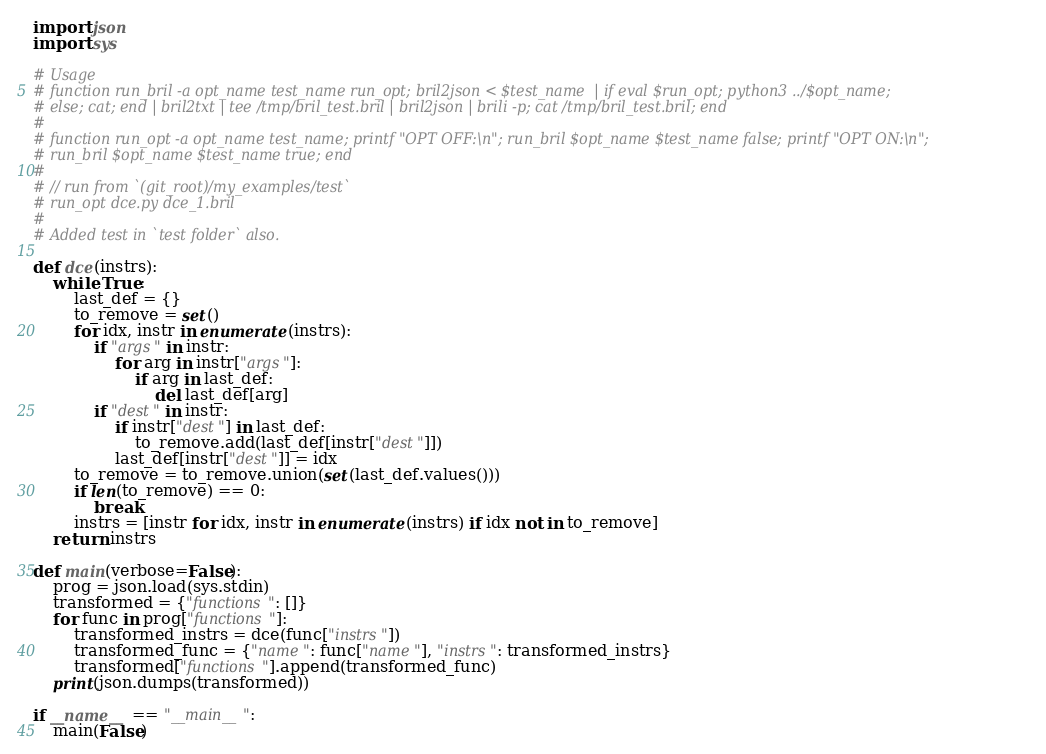Convert code to text. <code><loc_0><loc_0><loc_500><loc_500><_Python_>import json
import sys

# Usage
# function run_bril -a opt_name test_name run_opt; bril2json < $test_name  | if eval $run_opt; python3 ../$opt_name;
# else; cat; end | bril2txt | tee /tmp/bril_test.bril | bril2json | brili -p; cat /tmp/bril_test.bril; end
#
# function run_opt -a opt_name test_name; printf "OPT OFF:\n"; run_bril $opt_name $test_name false; printf "OPT ON:\n";
# run_bril $opt_name $test_name true; end
#
# // run from `(git_root)/my_examples/test`
# run_opt dce.py dce_1.bril
#
# Added test in `test folder` also.

def dce(instrs):
    while True:
        last_def = {}
        to_remove = set()
        for idx, instr in enumerate(instrs):
            if "args" in instr:
                for arg in instr["args"]:
                    if arg in last_def:
                        del last_def[arg]
            if "dest" in instr:
                if instr["dest"] in last_def:
                    to_remove.add(last_def[instr["dest"]])
                last_def[instr["dest"]] = idx
        to_remove = to_remove.union(set(last_def.values()))
        if len(to_remove) == 0:
            break
        instrs = [instr for idx, instr in enumerate(instrs) if idx not in to_remove]
    return instrs

def main(verbose=False):
    prog = json.load(sys.stdin)
    transformed = {"functions": []}
    for func in prog["functions"]:
        transformed_instrs = dce(func["instrs"])
        transformed_func = {"name": func["name"], "instrs": transformed_instrs}
        transformed["functions"].append(transformed_func)
    print(json.dumps(transformed))

if __name__ == "__main__":
    main(False)
</code> 